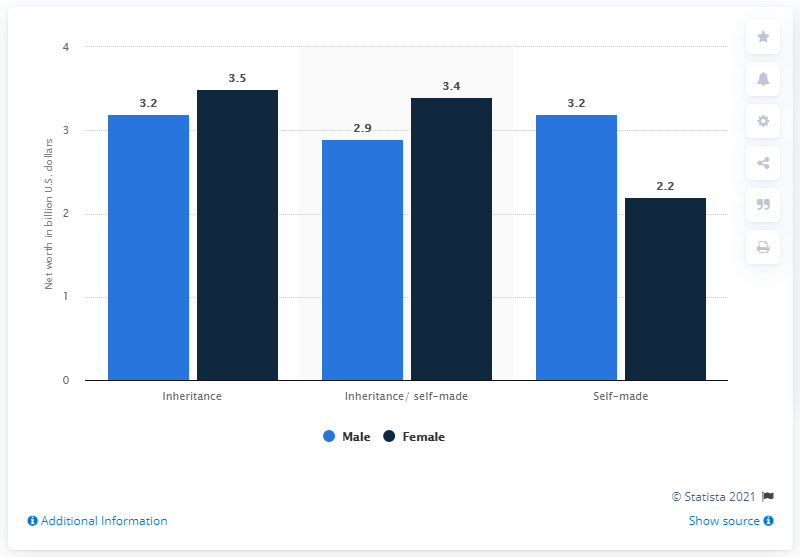Indicate a few pertinent items in this graphic. In 2014, the net worth of female billionaires who had inherited their wealth was estimated to be approximately 3.5. 